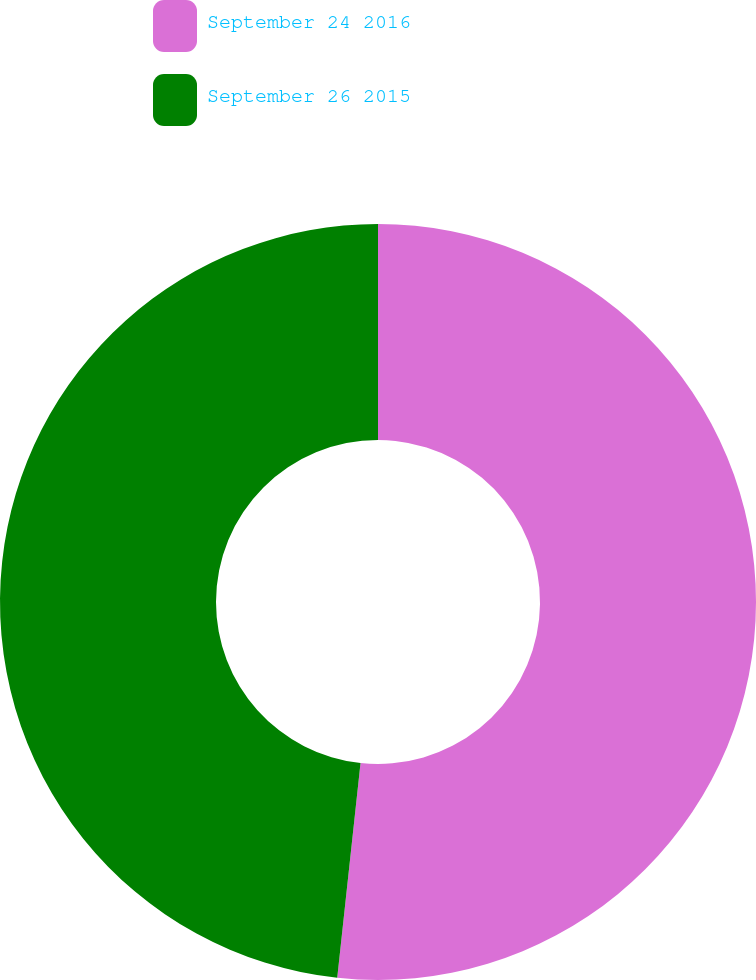<chart> <loc_0><loc_0><loc_500><loc_500><pie_chart><fcel>September 24 2016<fcel>September 26 2015<nl><fcel>51.72%<fcel>48.28%<nl></chart> 